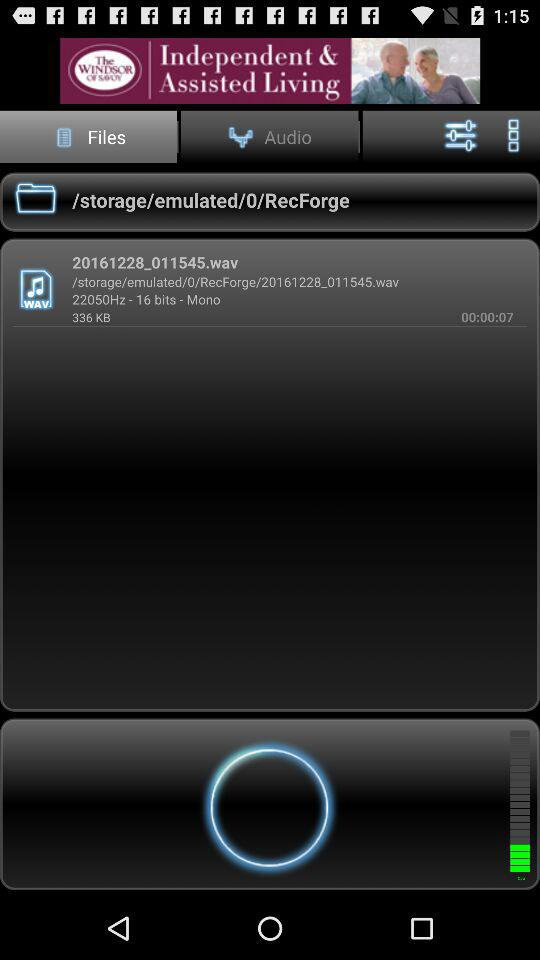How much space was consumed by the audio file? The space consumed by the audio file was 336 KB. 